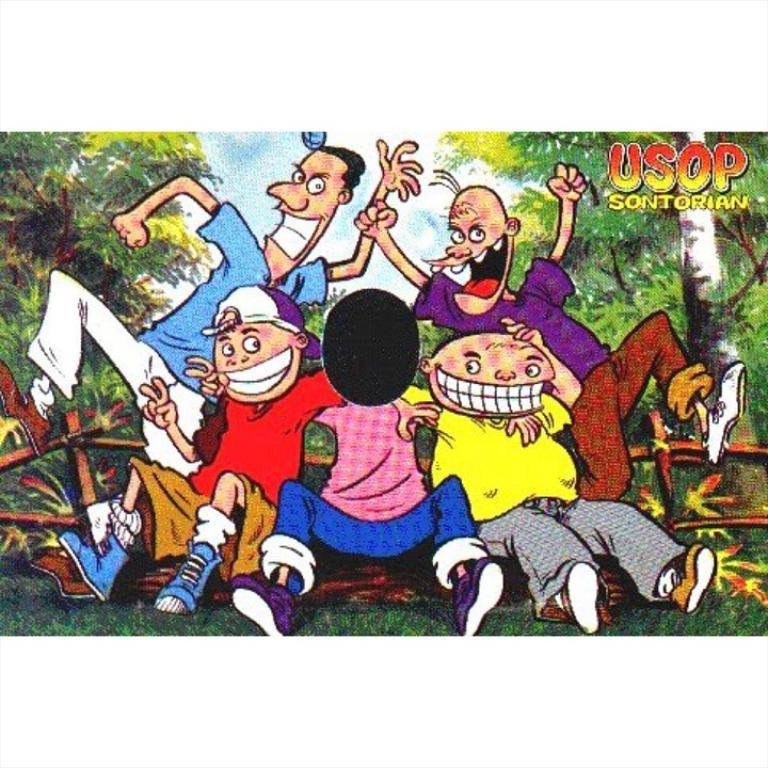What type of image is depicted in the picture? There is a picture of cartoons in the image. What can be seen in the background of the image? There are trees and sky visible in the background of the image. What type of ground is shown at the bottom of the image? There is grass at the bottom of the image. What type of credit does the farmer receive for his work in the image? There is no farmer or credit present in the image; it features a picture of cartoons with a background of trees, sky, and grass. 